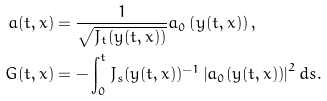Convert formula to latex. <formula><loc_0><loc_0><loc_500><loc_500>a ( t , x ) & = \frac { 1 } { \sqrt { J _ { t } ( y ( t , x ) ) } } a _ { 0 } \left ( y ( t , x ) \right ) , \\ G ( t , x ) & = - \int _ { 0 } ^ { t } J _ { s } ( y ( t , x ) ) ^ { - 1 } \left | a _ { 0 } ( y ( t , x ) ) \right | ^ { 2 } d s .</formula> 